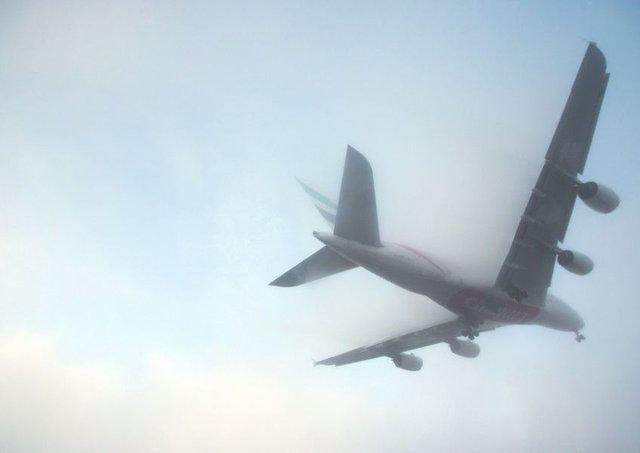Can you tell what might be the type of this airplane? The airplane in the image is likely a commercial passenger jet, based on its size and the configuration of multiple jet engines on the wings. The wing structure and engine placement suggest it's designed for carrying many passengers over significant distances. 